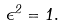Convert formula to latex. <formula><loc_0><loc_0><loc_500><loc_500>\epsilon ^ { 2 } = 1 .</formula> 